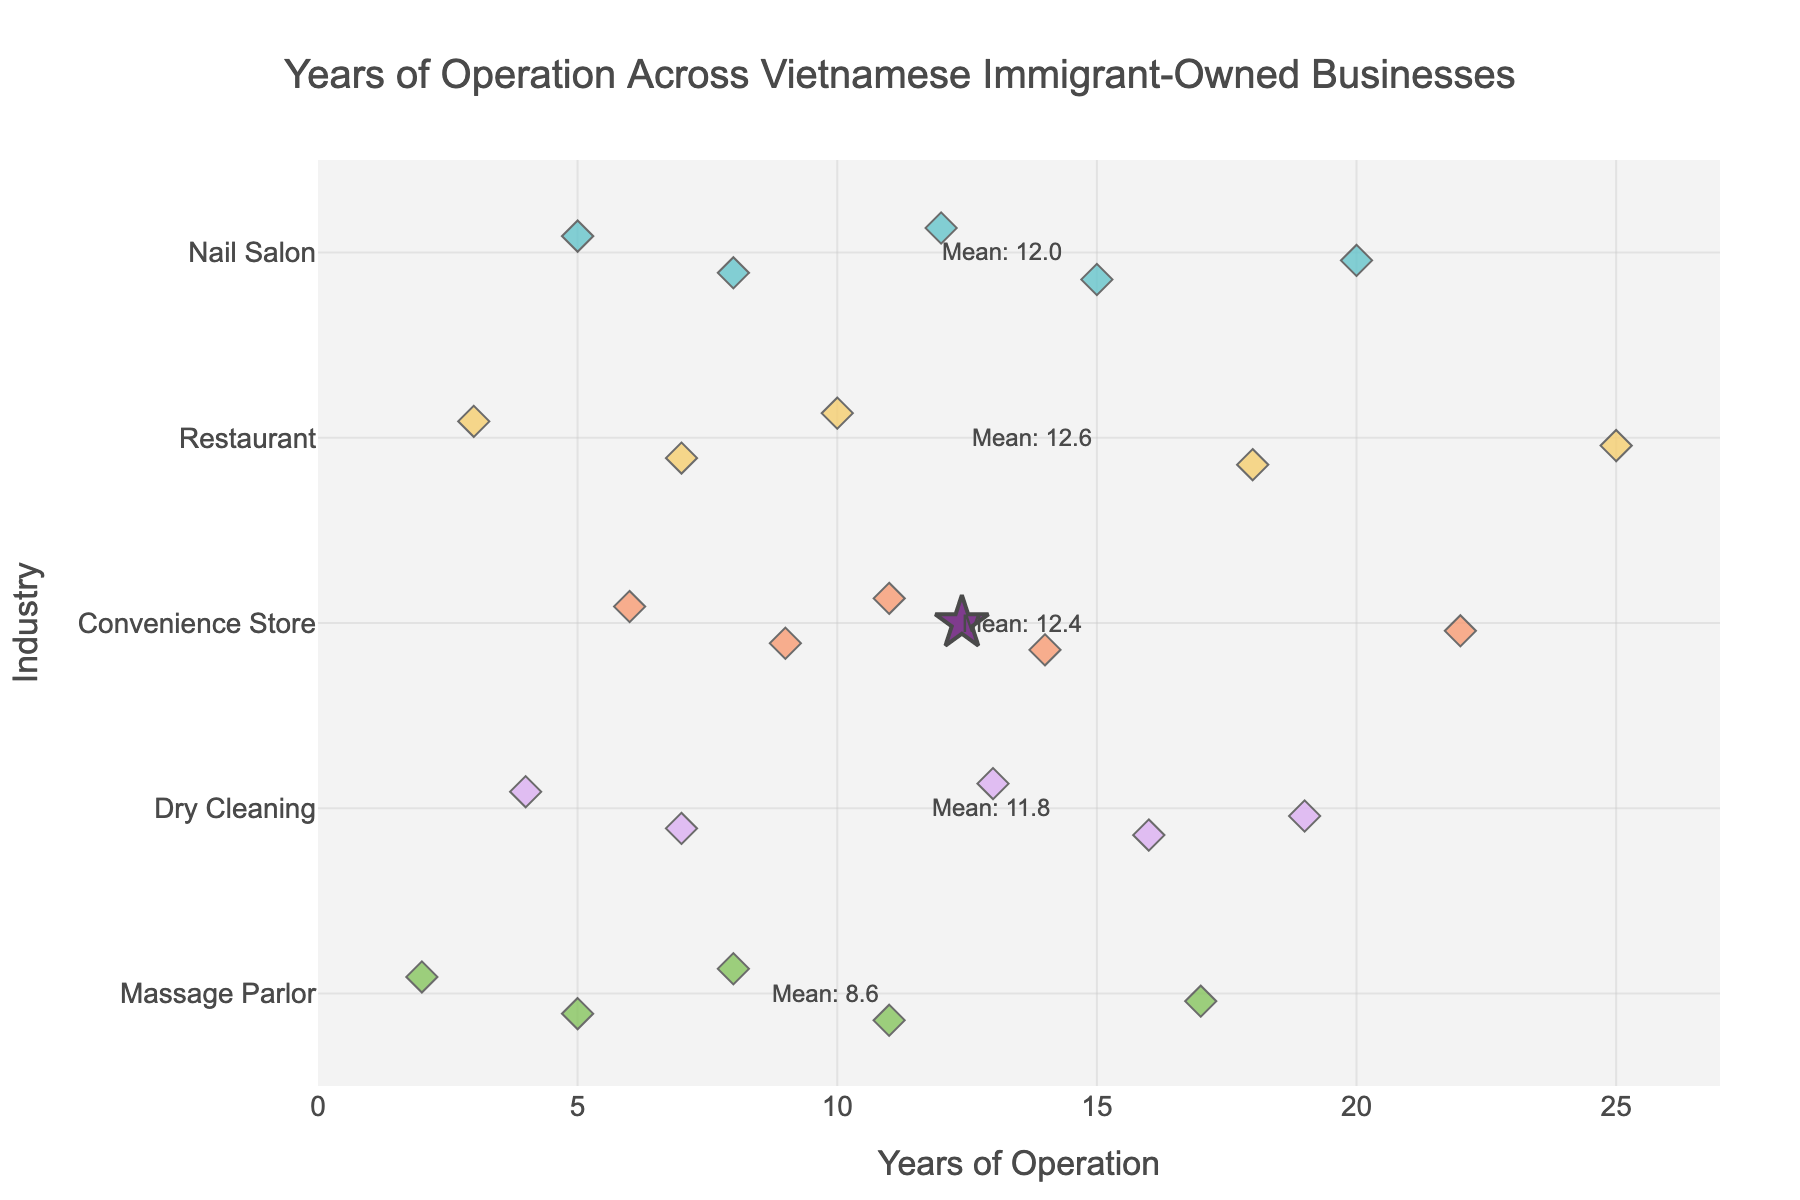What's the title of the strip plot? The title is located at the top center of the plot. It is clearly printed in a large font size. It reads: "Years of Operation Across Vietnamese Immigrant-Owned Businesses".
Answer: Years of Operation Across Vietnamese Immigrant-Owned Businesses How many sectors are shown in the strip plot? The y-axis lists all the sectors included in the plot. There are five sectors shown: Nail Salon, Restaurant, Convenience Store, Dry Cleaning, and Massage Parlor.
Answer: 5 What is the range of years of operation for nail salons? By looking along the "Nail Salon" row, we observe the lowest and highest data points. They range from 5 to 20 years.
Answer: 5 to 20 years Which industry has the longest operating business? Identify the longest bar within the entire plot. It is found in the "Restaurant" sector, where one business has operated for 25 years.
Answer: Restaurant What is the average years of operation for convenience stores? The star symbol in the Convenience Store row represents the average. The figure annotates this star with the mean value. The text annotation reads "Mean: 12.4", representing the average years of operation for the Convenience Store industry.
Answer: 12.4 years What is the longest operating business in the Massage Parlor sector? In the Massage Parlor row, look for the rightmost point. The farthest point in this row is 17 years.
Answer: 17 years Compare the average years of operation for Nail Salons and Dry Cleaning businesses. Which is longer? In the strip plot, compare the positions of the star symbols in both the Nail Salon and Dry Cleaning rows. The Nail Salon industry has an average operation period of 12.0 years, while the Dry Cleaning industry has an average of 11.8 years. Nail Salons have a slightly longer average operation period.
Answer: Nail Salons Based on the plot, which industry shows the greatest variability in years of operation? Variability is indicated by the spread of the points along the x-axis within each industry row. The Restaurant industry has the widest range, spanning from 3 to 25 years, indicating the greatest variability.
Answer: Restaurant What's the median years of operation for Nail Salons? To find the median, list the Nail Salon operation years in ascending order: 5, 8, 12, 15, 20. The middle value, 12, is the median.
Answer: 12 years 